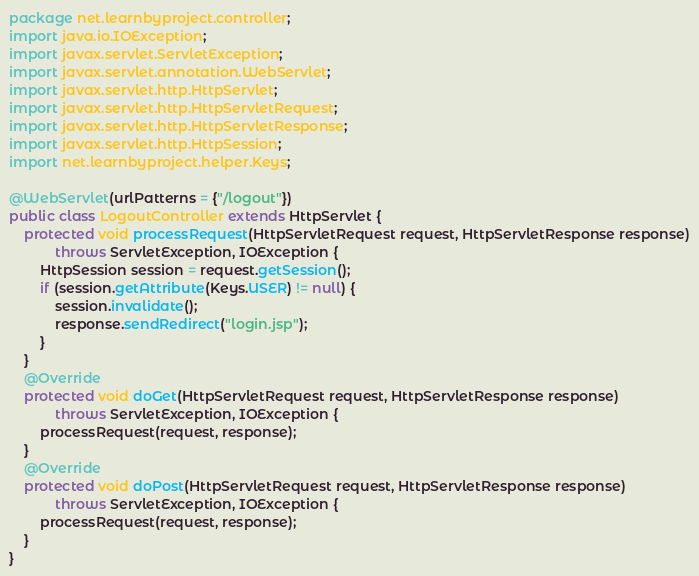<code> <loc_0><loc_0><loc_500><loc_500><_Java_>package net.learnbyproject.controller;
import java.io.IOException;
import javax.servlet.ServletException;
import javax.servlet.annotation.WebServlet;
import javax.servlet.http.HttpServlet;
import javax.servlet.http.HttpServletRequest;
import javax.servlet.http.HttpServletResponse;
import javax.servlet.http.HttpSession;
import net.learnbyproject.helper.Keys;

@WebServlet(urlPatterns = {"/logout"})
public class LogoutController extends HttpServlet {
    protected void processRequest(HttpServletRequest request, HttpServletResponse response)
            throws ServletException, IOException {
        HttpSession session = request.getSession();
        if (session.getAttribute(Keys.USER) != null) {
            session.invalidate();
            response.sendRedirect("login.jsp");
        }
    }
    @Override
    protected void doGet(HttpServletRequest request, HttpServletResponse response)
            throws ServletException, IOException {
        processRequest(request, response);
    }
    @Override
    protected void doPost(HttpServletRequest request, HttpServletResponse response)
            throws ServletException, IOException {
        processRequest(request, response);
    }
}
</code> 